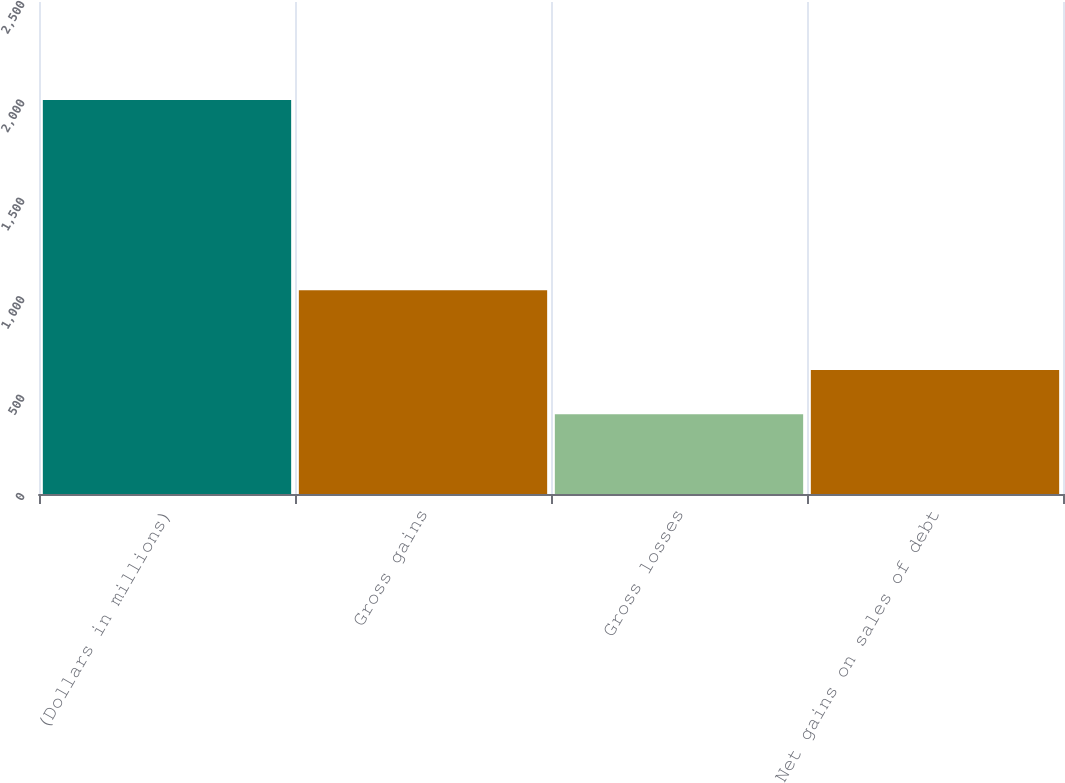<chart> <loc_0><loc_0><loc_500><loc_500><bar_chart><fcel>(Dollars in millions)<fcel>Gross gains<fcel>Gross losses<fcel>Net gains on sales of debt<nl><fcel>2002<fcel>1035<fcel>405<fcel>630<nl></chart> 